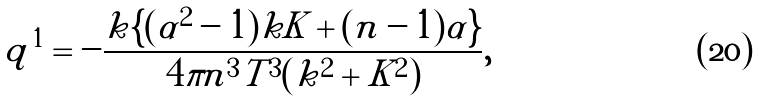Convert formula to latex. <formula><loc_0><loc_0><loc_500><loc_500>q ^ { 1 } = - \frac { k \{ ( \alpha ^ { 2 } - 1 ) k K + ( n - 1 ) \alpha \} } { 4 \pi n ^ { 3 } T ^ { 3 } ( k ^ { 2 } + K ^ { 2 } ) } ,</formula> 